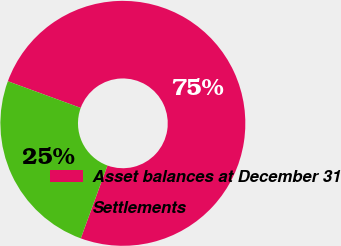Convert chart to OTSL. <chart><loc_0><loc_0><loc_500><loc_500><pie_chart><fcel>Asset balances at December 31<fcel>Settlements<nl><fcel>75.0%<fcel>25.0%<nl></chart> 